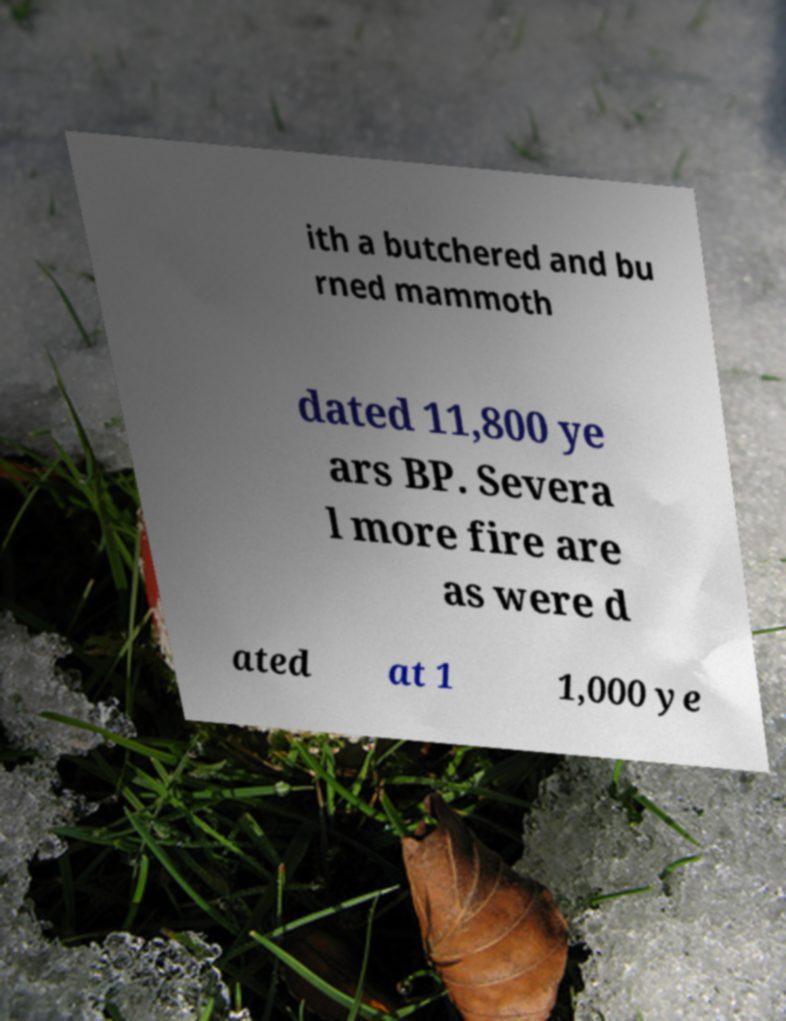Can you accurately transcribe the text from the provided image for me? ith a butchered and bu rned mammoth dated 11,800 ye ars BP. Severa l more fire are as were d ated at 1 1,000 ye 